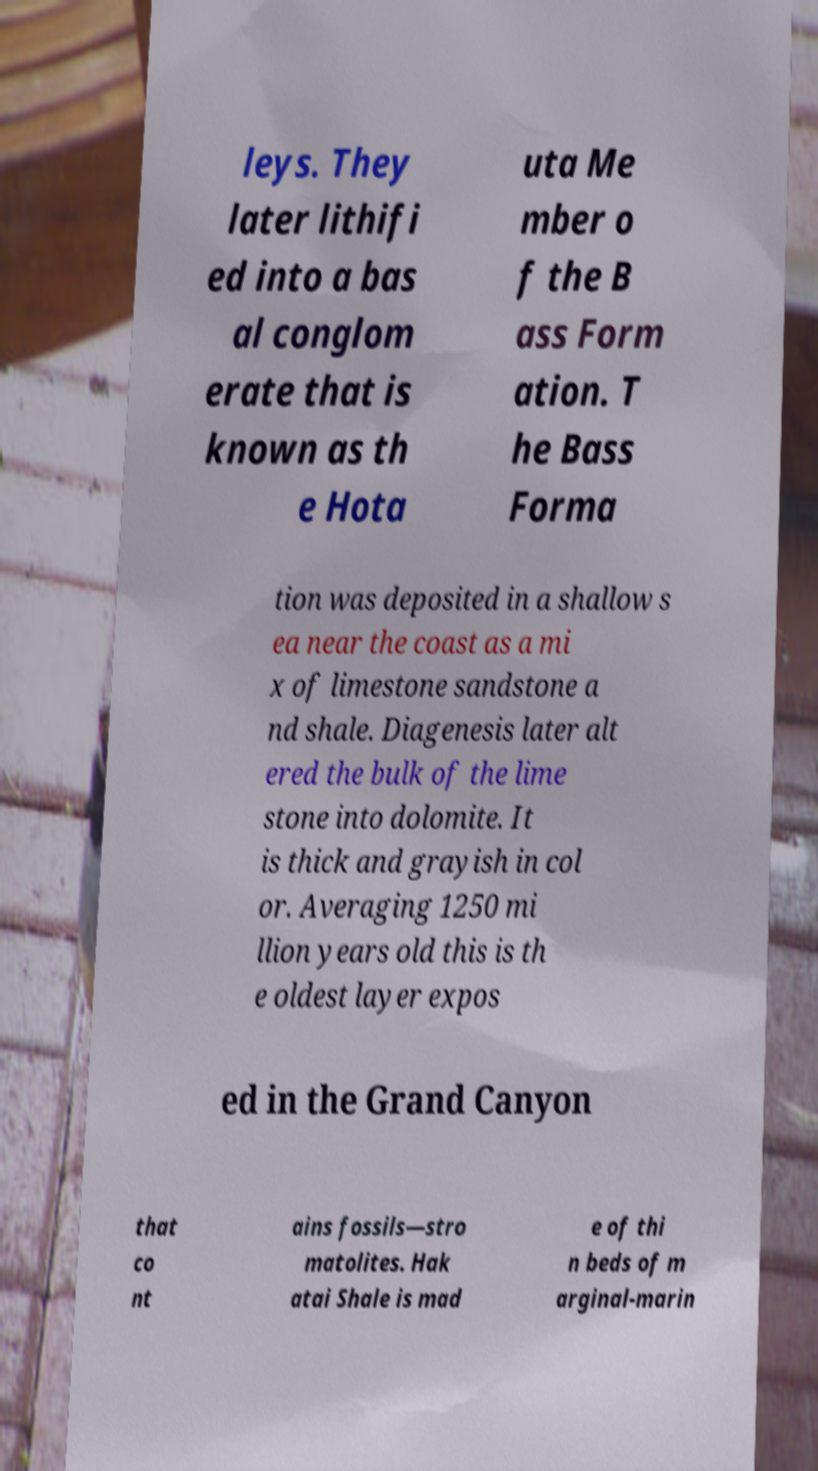Please read and relay the text visible in this image. What does it say? leys. They later lithifi ed into a bas al conglom erate that is known as th e Hota uta Me mber o f the B ass Form ation. T he Bass Forma tion was deposited in a shallow s ea near the coast as a mi x of limestone sandstone a nd shale. Diagenesis later alt ered the bulk of the lime stone into dolomite. It is thick and grayish in col or. Averaging 1250 mi llion years old this is th e oldest layer expos ed in the Grand Canyon that co nt ains fossils—stro matolites. Hak atai Shale is mad e of thi n beds of m arginal-marin 